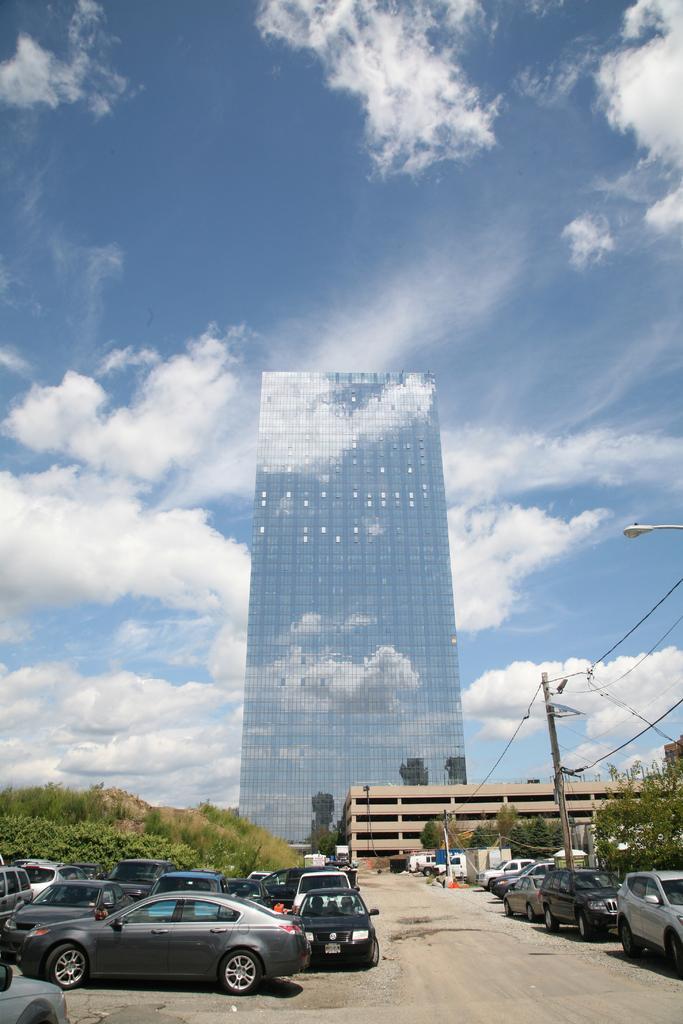Please provide a concise description of this image. In this image there are cars, trees, electric poles with cables on it, lamp posts and buildings, at the top of the image there are clouds in the sky. 